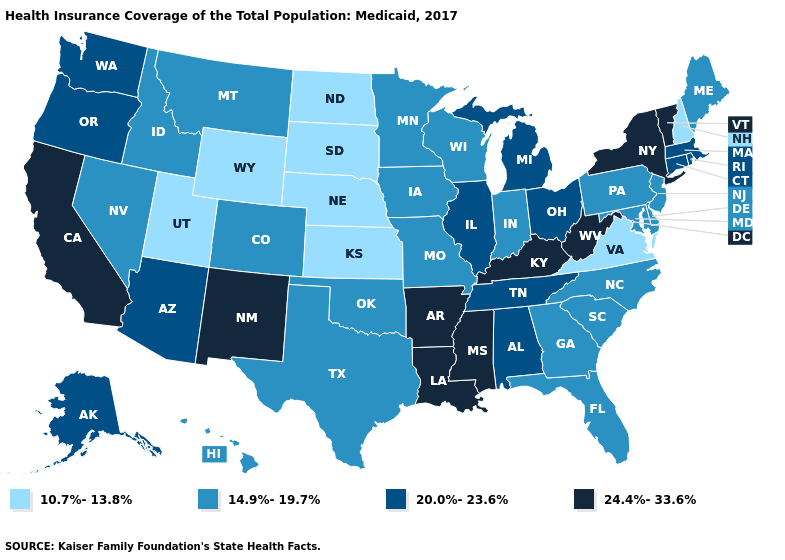What is the value of Louisiana?
Write a very short answer. 24.4%-33.6%. Which states have the lowest value in the South?
Be succinct. Virginia. What is the lowest value in states that border Idaho?
Quick response, please. 10.7%-13.8%. What is the value of Vermont?
Give a very brief answer. 24.4%-33.6%. Among the states that border New Jersey , which have the lowest value?
Short answer required. Delaware, Pennsylvania. What is the value of Vermont?
Give a very brief answer. 24.4%-33.6%. Does Ohio have a higher value than Oregon?
Give a very brief answer. No. Name the states that have a value in the range 20.0%-23.6%?
Keep it brief. Alabama, Alaska, Arizona, Connecticut, Illinois, Massachusetts, Michigan, Ohio, Oregon, Rhode Island, Tennessee, Washington. What is the lowest value in states that border Connecticut?
Keep it brief. 20.0%-23.6%. What is the highest value in states that border Massachusetts?
Short answer required. 24.4%-33.6%. What is the value of Massachusetts?
Write a very short answer. 20.0%-23.6%. Does Washington have the lowest value in the USA?
Keep it brief. No. What is the highest value in the West ?
Be succinct. 24.4%-33.6%. What is the value of North Dakota?
Write a very short answer. 10.7%-13.8%. What is the value of Louisiana?
Be succinct. 24.4%-33.6%. 